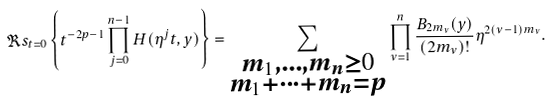Convert formula to latex. <formula><loc_0><loc_0><loc_500><loc_500>\Re s _ { t = 0 } \left \{ t ^ { - 2 p - 1 } \prod _ { j = 0 } ^ { n - 1 } H ( \eta ^ { j } t , y ) \right \} = \sum _ { \substack { m _ { 1 } , \dots , m _ { n } \geq 0 \\ m _ { 1 } + \cdots + m _ { n } = p } } \prod _ { \nu = 1 } ^ { n } \frac { B _ { 2 m _ { \nu } } ( y ) } { ( 2 m _ { \nu } ) ! } \eta ^ { 2 ( \nu - 1 ) m _ { \nu } } .</formula> 